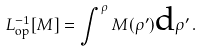<formula> <loc_0><loc_0><loc_500><loc_500>L _ { \text {op} } ^ { - 1 } [ M ] = \int ^ { \rho } M ( \rho ^ { \prime } ) \text {d} \rho ^ { \prime } \, .</formula> 